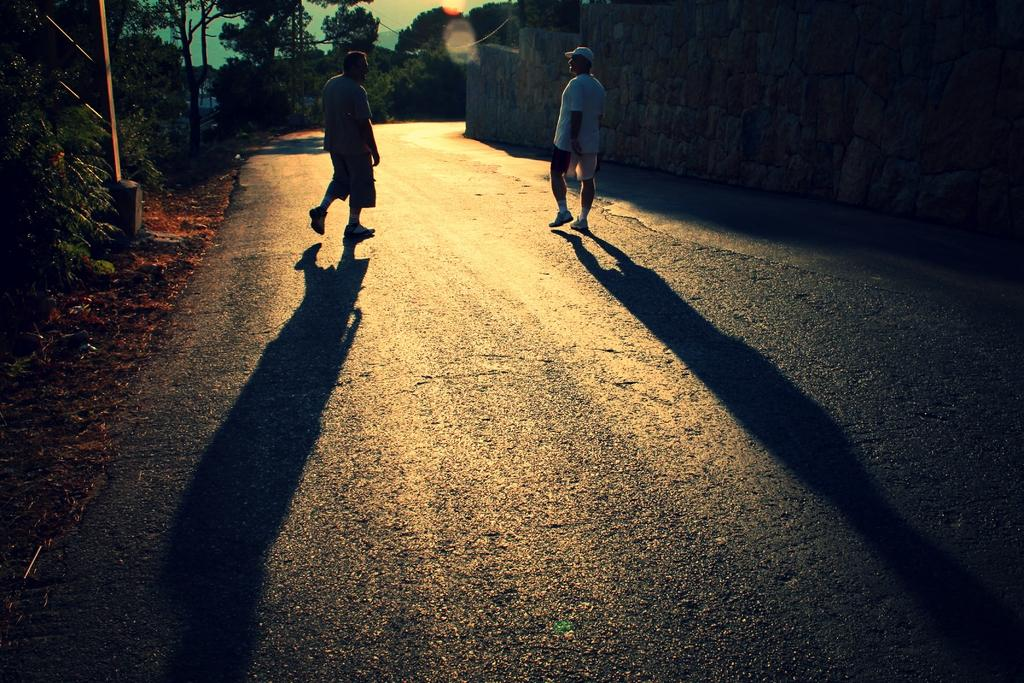How many people are walking in the image? There are two people walking in the image. What surface are the people walking on? The people are walking on a road. What other structures can be seen in the image? There is a wall, trees, and poles in the image. What is visible in the background of the image? The sky is visible in the background of the image. What type of record is being played by the trees in the image? There is no record or music player present in the image, and the trees are not playing any music. What color are the crayons used to draw the poles in the image? There are no crayons or drawings in the image; the poles are real structures. 